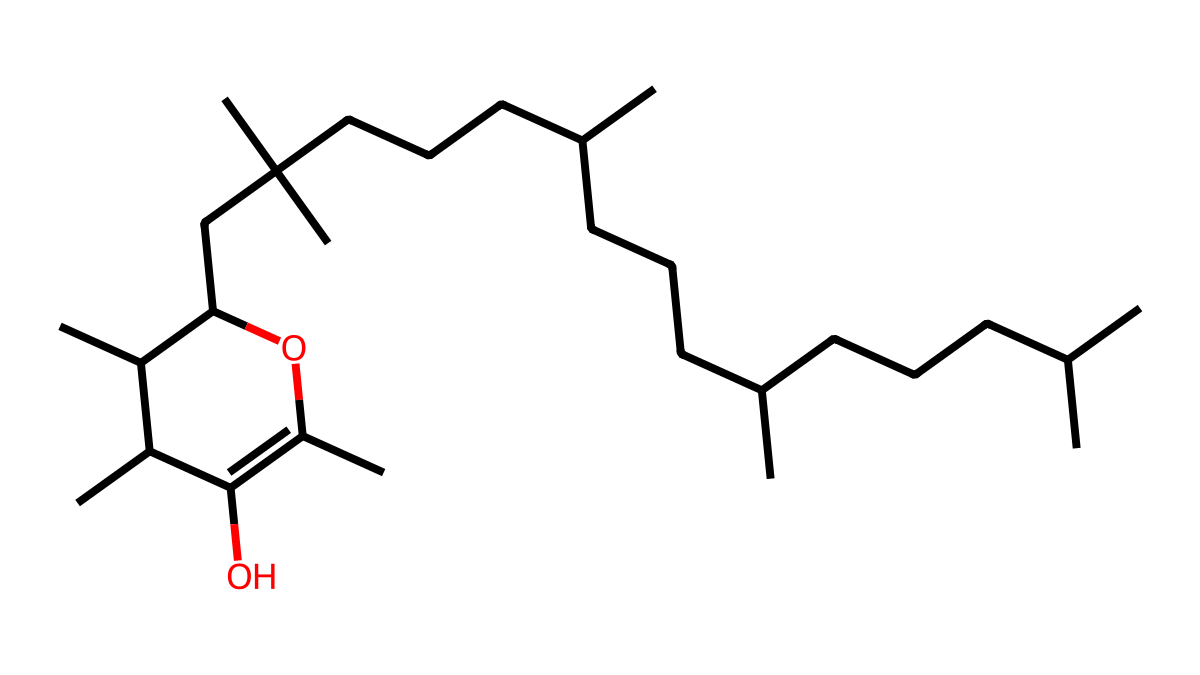How many hydroxyl (OH) groups are present in this molecule? The visible arrangement suggests that there are two black dots with lines that denote hydroxyl groups (indicated by the ‘O’ connected to carbon chains). Counting these, we see a total of two - one on each branch of the molecule.
Answer: two What is the number of carbon atoms in this structure? By reviewing the entire SMILES representation, we can track each carbon (C) symbol as it appears. If we count each instance, we find there are 29 carbon atoms present throughout the entire structure.
Answer: 29 What is the significance of the hydroxyl groups in tocopherol? Hydroxyl groups are crucial for the antioxidant properties of tocopherol as they engage in electron donation, neutralizing free radicals and protecting cellular components from oxidative stress.
Answer: antioxidant properties Does the structure indicate it is soluble in lipids? The large hydrocarbon chains (long carbon chains) suggest that this molecule is nonpolar and soluble in lipids, rather than water. The significant presence of carbon generally infers lipid solubility in organic environments.
Answer: yes What functional group class does tocopherol belong to? The presence of multiple hydroxyl (-OH) groups along with a large carbon skeleton classifies tocopherol as an alcohol, specifically a phenolic compound within the context of antioxidants.
Answer: alcohol 